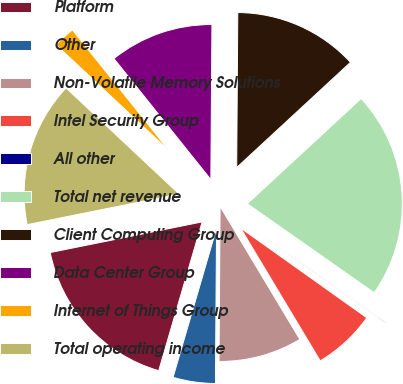Convert chart. <chart><loc_0><loc_0><loc_500><loc_500><pie_chart><fcel>Platform<fcel>Other<fcel>Non-Volatile Memory Solutions<fcel>Intel Security Group<fcel>All other<fcel>Total net revenue<fcel>Client Computing Group<fcel>Data Center Group<fcel>Internet of Things Group<fcel>Total operating income<nl><fcel>17.31%<fcel>4.41%<fcel>8.71%<fcel>6.56%<fcel>0.11%<fcel>21.61%<fcel>13.01%<fcel>10.86%<fcel>2.26%<fcel>15.16%<nl></chart> 